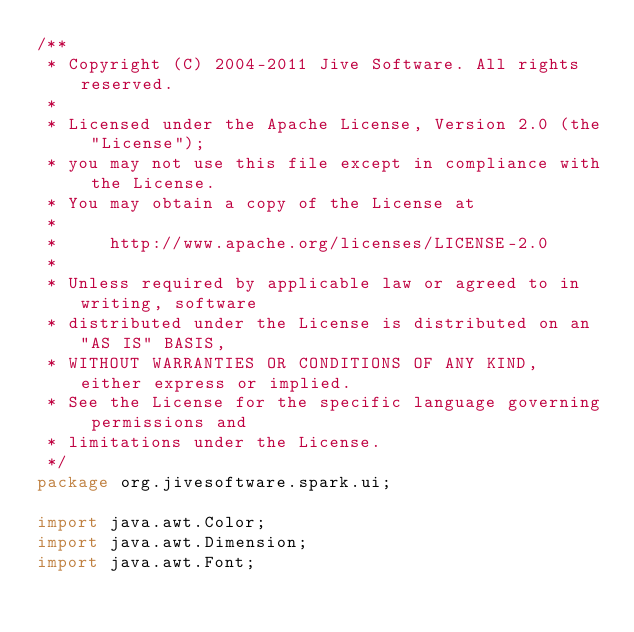Convert code to text. <code><loc_0><loc_0><loc_500><loc_500><_Java_>/**
 * Copyright (C) 2004-2011 Jive Software. All rights reserved.
 *
 * Licensed under the Apache License, Version 2.0 (the "License");
 * you may not use this file except in compliance with the License.
 * You may obtain a copy of the License at
 *
 *     http://www.apache.org/licenses/LICENSE-2.0
 *
 * Unless required by applicable law or agreed to in writing, software
 * distributed under the License is distributed on an "AS IS" BASIS,
 * WITHOUT WARRANTIES OR CONDITIONS OF ANY KIND, either express or implied.
 * See the License for the specific language governing permissions and
 * limitations under the License.
 */
package org.jivesoftware.spark.ui;

import java.awt.Color;
import java.awt.Dimension;
import java.awt.Font;</code> 